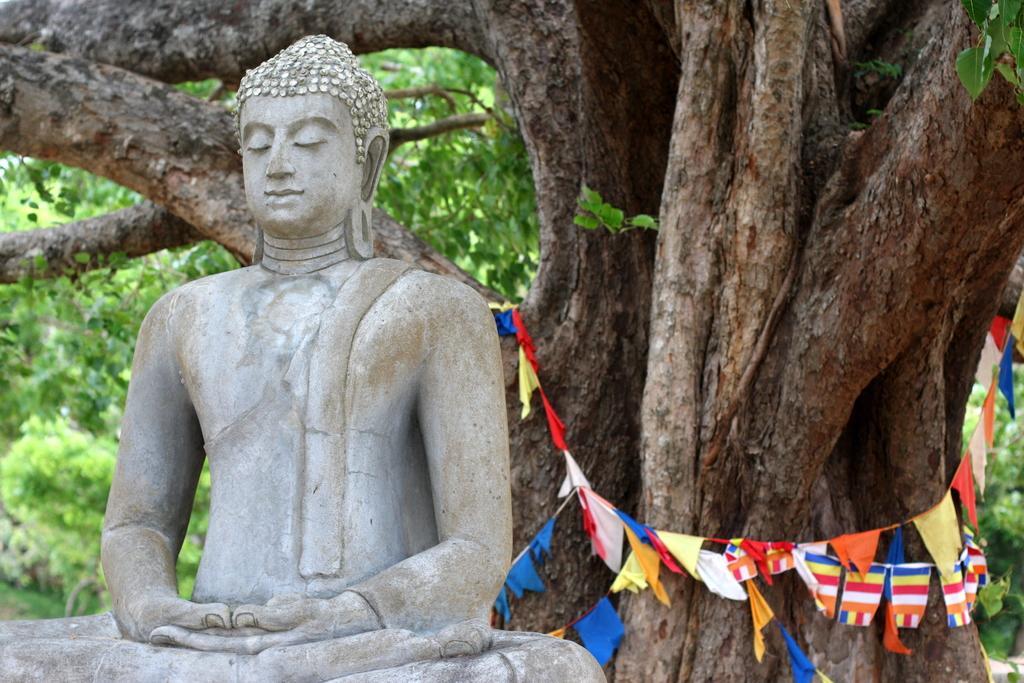How would you summarize this image in a sentence or two? In this image I can see the statue of the Buddha. In the background I can see few flags in multi color and I can see few trees in green color. 